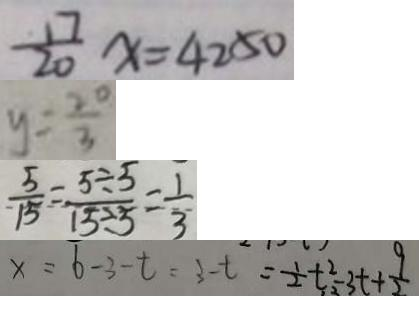Convert formula to latex. <formula><loc_0><loc_0><loc_500><loc_500>\frac { 1 7 } { 2 0 } x = 4 2 5 0 
 y = \frac { 2 0 } { 3 } 
 \frac { 5 } { 1 5 } = \frac { 5 \div 5 } { 1 5 \div 5 } = \frac { 1 } { 3 } 
 x = 6 - 3 - t = 3 - t = \frac { 1 } { 2 } t ^ { 2 } - 3 t + \frac { 9 } { 2 }</formula> 